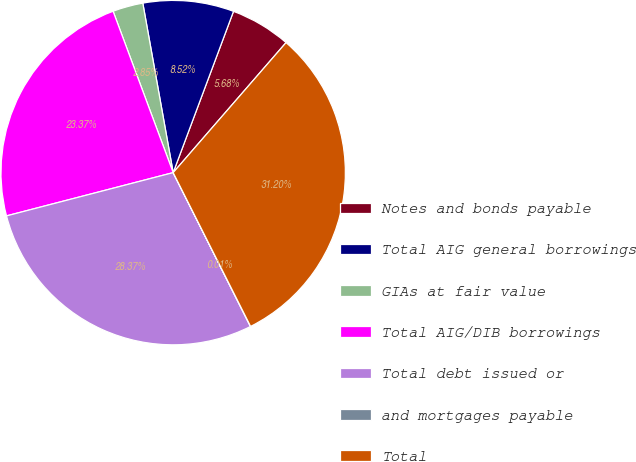Convert chart. <chart><loc_0><loc_0><loc_500><loc_500><pie_chart><fcel>Notes and bonds payable<fcel>Total AIG general borrowings<fcel>GIAs at fair value<fcel>Total AIG/DIB borrowings<fcel>Total debt issued or<fcel>and mortgages payable<fcel>Total<nl><fcel>5.68%<fcel>8.52%<fcel>2.85%<fcel>23.37%<fcel>28.37%<fcel>0.01%<fcel>31.2%<nl></chart> 